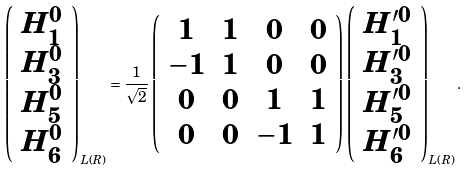<formula> <loc_0><loc_0><loc_500><loc_500>\left ( \begin{array} { c } H ^ { 0 } _ { 1 } \\ H ^ { 0 } _ { 3 } \\ H ^ { 0 } _ { 5 } \\ H ^ { 0 } _ { 6 } \end{array} \right ) _ { L ( R ) } = \frac { 1 } { \sqrt { 2 } } \left ( \begin{array} { c c c c } 1 & 1 & 0 & 0 \\ - 1 & 1 & 0 & 0 \\ 0 & 0 & 1 & 1 \\ 0 & 0 & - 1 & 1 \end{array} \right ) \left ( \begin{array} { c } H ^ { \prime 0 } _ { 1 } \\ H ^ { \prime 0 } _ { 3 } \\ H ^ { \prime 0 } _ { 5 } \\ H ^ { \prime 0 } _ { 6 } \end{array} \right ) _ { L ( R ) } .</formula> 